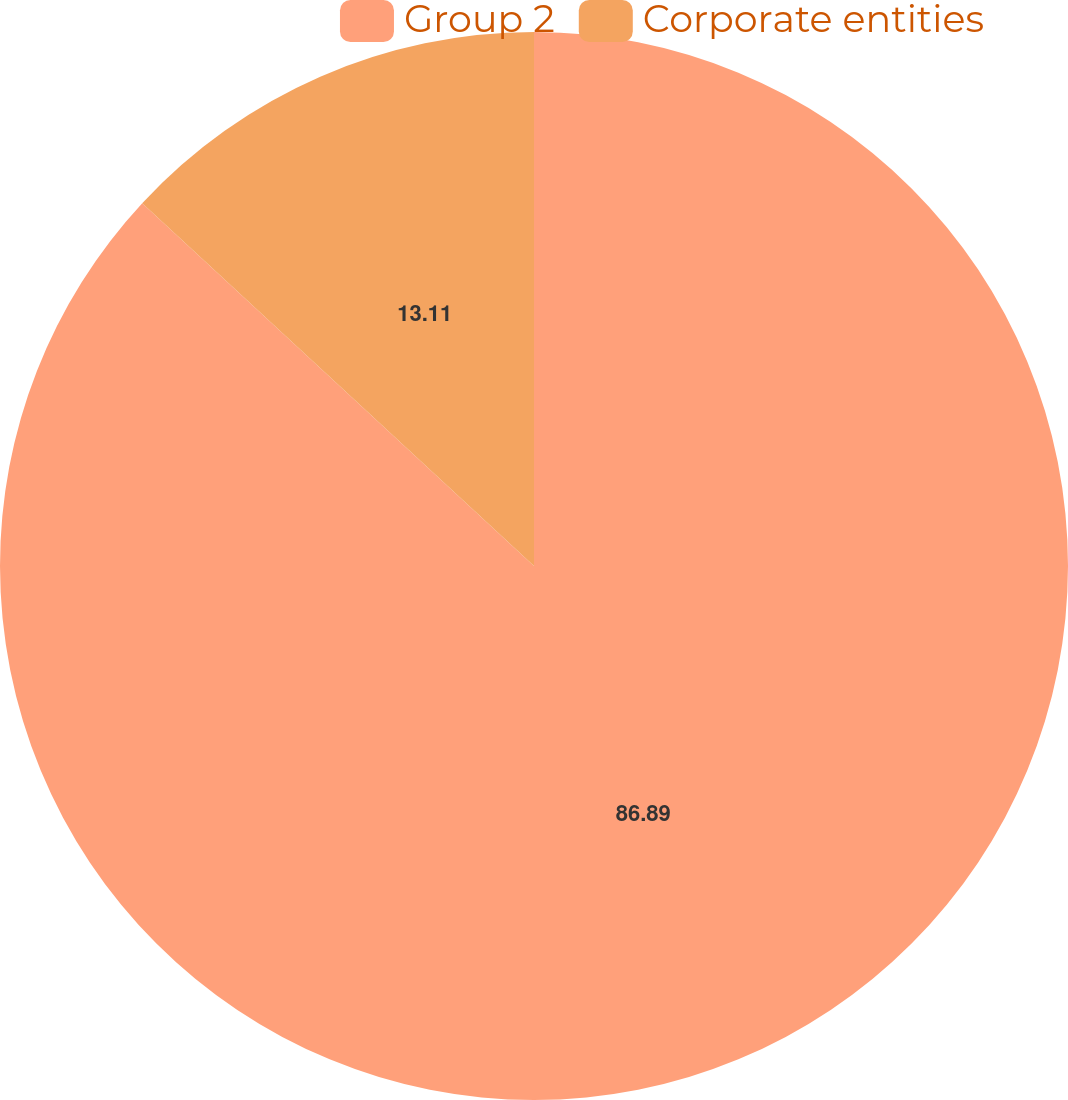<chart> <loc_0><loc_0><loc_500><loc_500><pie_chart><fcel>Group 2<fcel>Corporate entities<nl><fcel>86.89%<fcel>13.11%<nl></chart> 